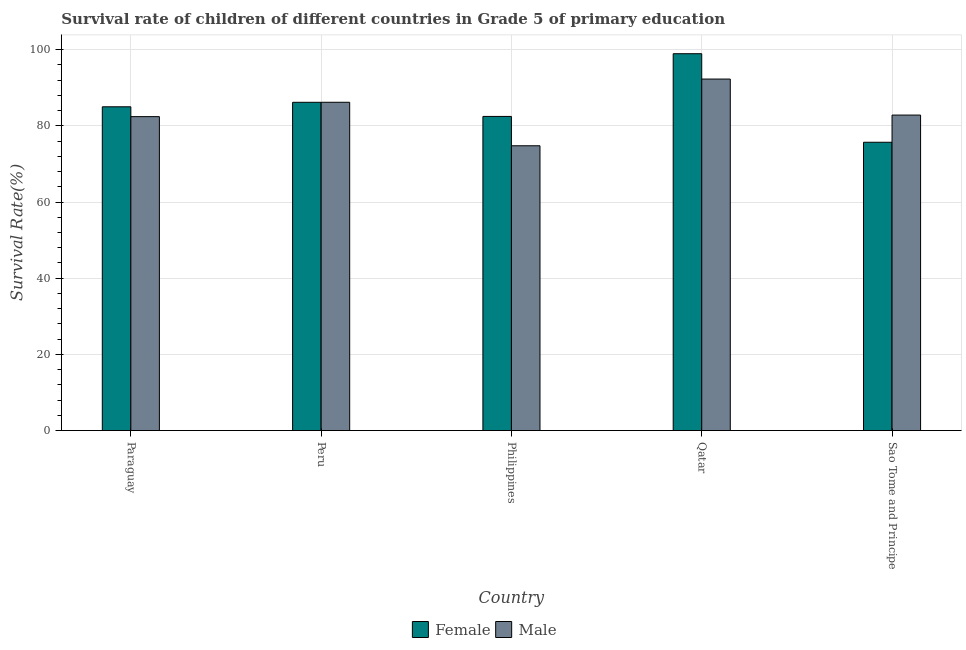How many different coloured bars are there?
Offer a terse response. 2. How many groups of bars are there?
Provide a succinct answer. 5. Are the number of bars per tick equal to the number of legend labels?
Your answer should be very brief. Yes. What is the survival rate of female students in primary education in Sao Tome and Principe?
Offer a very short reply. 75.69. Across all countries, what is the maximum survival rate of female students in primary education?
Give a very brief answer. 98.94. Across all countries, what is the minimum survival rate of female students in primary education?
Provide a succinct answer. 75.69. In which country was the survival rate of male students in primary education maximum?
Provide a short and direct response. Qatar. In which country was the survival rate of male students in primary education minimum?
Your response must be concise. Philippines. What is the total survival rate of female students in primary education in the graph?
Ensure brevity in your answer.  428.3. What is the difference between the survival rate of male students in primary education in Qatar and that in Sao Tome and Principe?
Your answer should be compact. 9.45. What is the difference between the survival rate of male students in primary education in Qatar and the survival rate of female students in primary education in Peru?
Your response must be concise. 6.1. What is the average survival rate of female students in primary education per country?
Offer a very short reply. 85.66. What is the difference between the survival rate of male students in primary education and survival rate of female students in primary education in Peru?
Provide a short and direct response. 0.01. In how many countries, is the survival rate of female students in primary education greater than 68 %?
Make the answer very short. 5. What is the ratio of the survival rate of female students in primary education in Paraguay to that in Qatar?
Your response must be concise. 0.86. Is the survival rate of male students in primary education in Paraguay less than that in Sao Tome and Principe?
Provide a succinct answer. Yes. What is the difference between the highest and the second highest survival rate of female students in primary education?
Make the answer very short. 12.76. What is the difference between the highest and the lowest survival rate of male students in primary education?
Ensure brevity in your answer.  17.51. What does the 2nd bar from the right in Philippines represents?
Keep it short and to the point. Female. How many bars are there?
Provide a short and direct response. 10. How many countries are there in the graph?
Offer a terse response. 5. Are the values on the major ticks of Y-axis written in scientific E-notation?
Offer a terse response. No. How many legend labels are there?
Keep it short and to the point. 2. What is the title of the graph?
Your answer should be compact. Survival rate of children of different countries in Grade 5 of primary education. Does "Borrowers" appear as one of the legend labels in the graph?
Your answer should be compact. No. What is the label or title of the X-axis?
Provide a succinct answer. Country. What is the label or title of the Y-axis?
Provide a short and direct response. Survival Rate(%). What is the Survival Rate(%) of Female in Paraguay?
Your answer should be very brief. 85.01. What is the Survival Rate(%) of Male in Paraguay?
Provide a short and direct response. 82.42. What is the Survival Rate(%) of Female in Peru?
Give a very brief answer. 86.18. What is the Survival Rate(%) of Male in Peru?
Your response must be concise. 86.19. What is the Survival Rate(%) of Female in Philippines?
Give a very brief answer. 82.48. What is the Survival Rate(%) of Male in Philippines?
Offer a very short reply. 74.77. What is the Survival Rate(%) in Female in Qatar?
Your response must be concise. 98.94. What is the Survival Rate(%) of Male in Qatar?
Offer a very short reply. 92.29. What is the Survival Rate(%) of Female in Sao Tome and Principe?
Your response must be concise. 75.69. What is the Survival Rate(%) of Male in Sao Tome and Principe?
Ensure brevity in your answer.  82.83. Across all countries, what is the maximum Survival Rate(%) in Female?
Your answer should be very brief. 98.94. Across all countries, what is the maximum Survival Rate(%) of Male?
Keep it short and to the point. 92.29. Across all countries, what is the minimum Survival Rate(%) in Female?
Give a very brief answer. 75.69. Across all countries, what is the minimum Survival Rate(%) in Male?
Provide a succinct answer. 74.77. What is the total Survival Rate(%) in Female in the graph?
Your answer should be very brief. 428.3. What is the total Survival Rate(%) in Male in the graph?
Your answer should be very brief. 418.5. What is the difference between the Survival Rate(%) of Female in Paraguay and that in Peru?
Keep it short and to the point. -1.18. What is the difference between the Survival Rate(%) of Male in Paraguay and that in Peru?
Provide a short and direct response. -3.77. What is the difference between the Survival Rate(%) of Female in Paraguay and that in Philippines?
Your answer should be very brief. 2.53. What is the difference between the Survival Rate(%) in Male in Paraguay and that in Philippines?
Ensure brevity in your answer.  7.65. What is the difference between the Survival Rate(%) of Female in Paraguay and that in Qatar?
Your answer should be compact. -13.93. What is the difference between the Survival Rate(%) in Male in Paraguay and that in Qatar?
Offer a terse response. -9.86. What is the difference between the Survival Rate(%) in Female in Paraguay and that in Sao Tome and Principe?
Your answer should be very brief. 9.31. What is the difference between the Survival Rate(%) in Male in Paraguay and that in Sao Tome and Principe?
Offer a very short reply. -0.41. What is the difference between the Survival Rate(%) in Female in Peru and that in Philippines?
Keep it short and to the point. 3.71. What is the difference between the Survival Rate(%) of Male in Peru and that in Philippines?
Your response must be concise. 11.42. What is the difference between the Survival Rate(%) of Female in Peru and that in Qatar?
Provide a succinct answer. -12.76. What is the difference between the Survival Rate(%) in Male in Peru and that in Qatar?
Your answer should be very brief. -6.1. What is the difference between the Survival Rate(%) in Female in Peru and that in Sao Tome and Principe?
Ensure brevity in your answer.  10.49. What is the difference between the Survival Rate(%) of Male in Peru and that in Sao Tome and Principe?
Your answer should be compact. 3.36. What is the difference between the Survival Rate(%) of Female in Philippines and that in Qatar?
Offer a very short reply. -16.46. What is the difference between the Survival Rate(%) of Male in Philippines and that in Qatar?
Your answer should be compact. -17.51. What is the difference between the Survival Rate(%) in Female in Philippines and that in Sao Tome and Principe?
Make the answer very short. 6.78. What is the difference between the Survival Rate(%) in Male in Philippines and that in Sao Tome and Principe?
Offer a terse response. -8.06. What is the difference between the Survival Rate(%) in Female in Qatar and that in Sao Tome and Principe?
Your answer should be compact. 23.24. What is the difference between the Survival Rate(%) in Male in Qatar and that in Sao Tome and Principe?
Ensure brevity in your answer.  9.45. What is the difference between the Survival Rate(%) in Female in Paraguay and the Survival Rate(%) in Male in Peru?
Your response must be concise. -1.18. What is the difference between the Survival Rate(%) of Female in Paraguay and the Survival Rate(%) of Male in Philippines?
Offer a terse response. 10.24. What is the difference between the Survival Rate(%) in Female in Paraguay and the Survival Rate(%) in Male in Qatar?
Offer a terse response. -7.28. What is the difference between the Survival Rate(%) in Female in Paraguay and the Survival Rate(%) in Male in Sao Tome and Principe?
Provide a succinct answer. 2.17. What is the difference between the Survival Rate(%) in Female in Peru and the Survival Rate(%) in Male in Philippines?
Offer a terse response. 11.41. What is the difference between the Survival Rate(%) in Female in Peru and the Survival Rate(%) in Male in Qatar?
Offer a terse response. -6.1. What is the difference between the Survival Rate(%) in Female in Peru and the Survival Rate(%) in Male in Sao Tome and Principe?
Your answer should be very brief. 3.35. What is the difference between the Survival Rate(%) of Female in Philippines and the Survival Rate(%) of Male in Qatar?
Keep it short and to the point. -9.81. What is the difference between the Survival Rate(%) of Female in Philippines and the Survival Rate(%) of Male in Sao Tome and Principe?
Offer a terse response. -0.36. What is the difference between the Survival Rate(%) of Female in Qatar and the Survival Rate(%) of Male in Sao Tome and Principe?
Provide a short and direct response. 16.11. What is the average Survival Rate(%) in Female per country?
Your response must be concise. 85.66. What is the average Survival Rate(%) of Male per country?
Your answer should be very brief. 83.7. What is the difference between the Survival Rate(%) in Female and Survival Rate(%) in Male in Paraguay?
Provide a short and direct response. 2.59. What is the difference between the Survival Rate(%) in Female and Survival Rate(%) in Male in Peru?
Provide a succinct answer. -0.01. What is the difference between the Survival Rate(%) in Female and Survival Rate(%) in Male in Philippines?
Offer a very short reply. 7.7. What is the difference between the Survival Rate(%) in Female and Survival Rate(%) in Male in Qatar?
Provide a short and direct response. 6.65. What is the difference between the Survival Rate(%) in Female and Survival Rate(%) in Male in Sao Tome and Principe?
Give a very brief answer. -7.14. What is the ratio of the Survival Rate(%) in Female in Paraguay to that in Peru?
Ensure brevity in your answer.  0.99. What is the ratio of the Survival Rate(%) in Male in Paraguay to that in Peru?
Make the answer very short. 0.96. What is the ratio of the Survival Rate(%) of Female in Paraguay to that in Philippines?
Offer a terse response. 1.03. What is the ratio of the Survival Rate(%) of Male in Paraguay to that in Philippines?
Provide a short and direct response. 1.1. What is the ratio of the Survival Rate(%) in Female in Paraguay to that in Qatar?
Your answer should be very brief. 0.86. What is the ratio of the Survival Rate(%) in Male in Paraguay to that in Qatar?
Your answer should be compact. 0.89. What is the ratio of the Survival Rate(%) in Female in Paraguay to that in Sao Tome and Principe?
Ensure brevity in your answer.  1.12. What is the ratio of the Survival Rate(%) of Female in Peru to that in Philippines?
Make the answer very short. 1.04. What is the ratio of the Survival Rate(%) in Male in Peru to that in Philippines?
Offer a very short reply. 1.15. What is the ratio of the Survival Rate(%) in Female in Peru to that in Qatar?
Make the answer very short. 0.87. What is the ratio of the Survival Rate(%) of Male in Peru to that in Qatar?
Offer a very short reply. 0.93. What is the ratio of the Survival Rate(%) in Female in Peru to that in Sao Tome and Principe?
Make the answer very short. 1.14. What is the ratio of the Survival Rate(%) of Male in Peru to that in Sao Tome and Principe?
Offer a terse response. 1.04. What is the ratio of the Survival Rate(%) in Female in Philippines to that in Qatar?
Provide a succinct answer. 0.83. What is the ratio of the Survival Rate(%) in Male in Philippines to that in Qatar?
Provide a succinct answer. 0.81. What is the ratio of the Survival Rate(%) in Female in Philippines to that in Sao Tome and Principe?
Make the answer very short. 1.09. What is the ratio of the Survival Rate(%) of Male in Philippines to that in Sao Tome and Principe?
Your response must be concise. 0.9. What is the ratio of the Survival Rate(%) of Female in Qatar to that in Sao Tome and Principe?
Offer a very short reply. 1.31. What is the ratio of the Survival Rate(%) in Male in Qatar to that in Sao Tome and Principe?
Offer a very short reply. 1.11. What is the difference between the highest and the second highest Survival Rate(%) of Female?
Provide a short and direct response. 12.76. What is the difference between the highest and the second highest Survival Rate(%) of Male?
Provide a succinct answer. 6.1. What is the difference between the highest and the lowest Survival Rate(%) in Female?
Make the answer very short. 23.24. What is the difference between the highest and the lowest Survival Rate(%) of Male?
Provide a short and direct response. 17.51. 